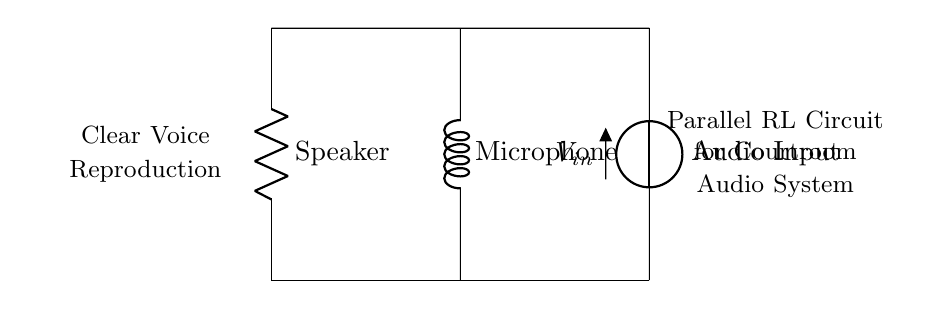What is the voltage source in the circuit? The voltage source is labeled as V in the diagram, specifically indicated as the audio input. This represents the external electrical energy supplied to the circuit.
Answer: Audio Input What components are present in the circuit? The components in the circuit are a resistor, an inductor, and a voltage source. The resistor is labeled as R (the speaker), the inductor is labeled as L (the microphone), and the voltage source is V (the audio input).
Answer: Resistor, Inductor, Voltage Source What is the role of the resistor in this circuit? The resistor functions as the speaker in this parallel RL circuit. Its role is to dissipate electrical energy as heat and thus produce sound waves, providing clear voice reproduction.
Answer: Speaker What are the total impedance characteristics of a parallel RL circuit? In a parallel RL circuit, the total impedance is determined by the individual resistive and inductive reactances acting together. The total impedance is less than the smallest individual impedance, which facilitates easier current flow while maintaining functionality for audio signals.
Answer: Less than smallest individual impedance What happens to the current through the inductor at high frequencies? At high frequencies, the inductor presents low reactance, causing more current to flow through it. This allows high-frequency audio signals to be better captured by the microphone. Consequently, this enhances voice clarity in courtroom audio systems.
Answer: More current flows through What does the connection between the elements suggest about signal clarity? The parallel arrangement of the resistor and inductor suggests that both the speaker and microphone can operate independently, allowing for simultaneous sound reproduction and recording. This configuration optimizes signal clarity and minimizes distortion.
Answer: Optimizes signal clarity How does this circuit configuration enhance audio performance in a courtroom? The parallel RL configuration allows for a direct comparison of sound levels between the microphone and speaker, leading to improved audio quality. By balancing the resistive and inductive elements, the system achieves greater fidelity without interference, which is crucial in legal settings.
Answer: Enhanced audio quality 